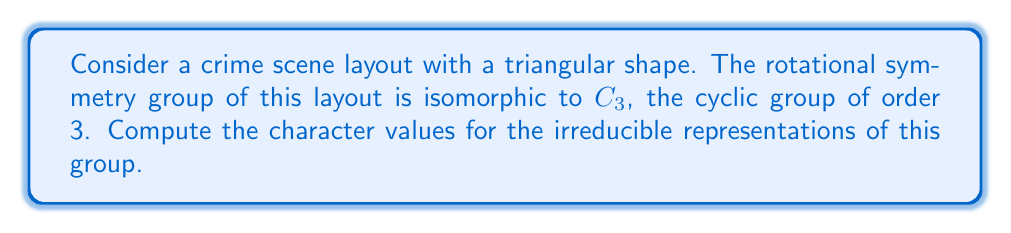Teach me how to tackle this problem. Let's approach this step-by-step:

1) The cyclic group $C_3$ has three elements: $e$ (identity), $r$ (rotation by $120^\circ$), and $r^2$ (rotation by $240^\circ$).

2) For a cyclic group of order $n$, there are always $n$ irreducible representations, each of dimension 1.

3) The irreducible representations of $C_3$ are given by:

   $\chi_j(r^k) = e^{2\pi ijk/3}$, where $i$ is the imaginary unit, $j = 0, 1, 2$, and $k = 0, 1, 2$.

4) Let's compute the character values for each representation:

   For $\chi_0$ (trivial representation):
   $\chi_0(e) = 1$
   $\chi_0(r) = 1$
   $\chi_0(r^2) = 1$

   For $\chi_1$:
   $\chi_1(e) = e^0 = 1$
   $\chi_1(r) = e^{2\pi i/3} = -\frac{1}{2} + i\frac{\sqrt{3}}{2}$
   $\chi_1(r^2) = e^{4\pi i/3} = -\frac{1}{2} - i\frac{\sqrt{3}}{2}$

   For $\chi_2$:
   $\chi_2(e) = e^0 = 1$
   $\chi_2(r) = e^{4\pi i/3} = -\frac{1}{2} - i\frac{\sqrt{3}}{2}$
   $\chi_2(r^2) = e^{8\pi i/3} = -\frac{1}{2} + i\frac{\sqrt{3}}{2}$

5) We can represent these values in a character table:

   $$
   \begin{array}{c|ccc}
    C_3 & e & r & r^2 \\
   \hline
   \chi_0 & 1 & 1 & 1 \\
   \chi_1 & 1 & -\frac{1}{2} + i\frac{\sqrt{3}}{2} & -\frac{1}{2} - i\frac{\sqrt{3}}{2} \\
   \chi_2 & 1 & -\frac{1}{2} - i\frac{\sqrt{3}}{2} & -\frac{1}{2} + i\frac{\sqrt{3}}{2}
   \end{array}
   $$

This character table completely describes the irreducible representations of the rotational symmetry group of the triangular crime scene layout.
Answer: $\chi_0: (1, 1, 1)$, $\chi_1: (1, -\frac{1}{2} + i\frac{\sqrt{3}}{2}, -\frac{1}{2} - i\frac{\sqrt{3}}{2})$, $\chi_2: (1, -\frac{1}{2} - i\frac{\sqrt{3}}{2}, -\frac{1}{2} + i\frac{\sqrt{3}}{2})$ 